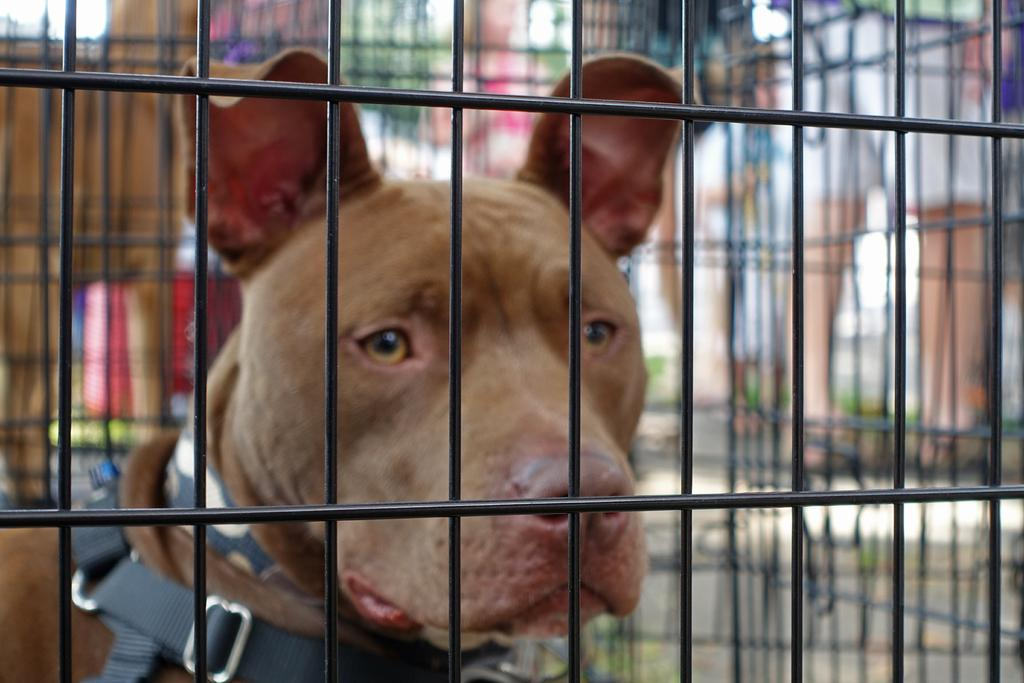What is the main subject in the center of the image? There is an animal in the center of the image. What is located in front of the animal? There is a black color cage in front of the animal. How would you describe the background of the image? The background of the image is blurry. What type of pain is the animal experiencing in the image? There is no indication of pain in the image, and we cannot determine the animal's emotional state from the provided facts. 